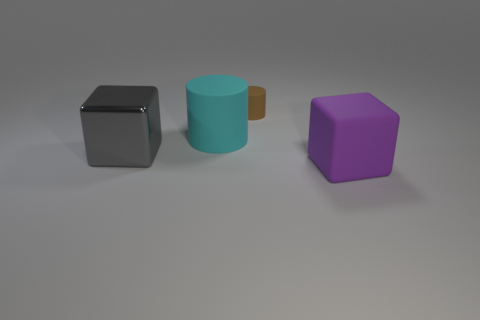Is the size of the cyan matte object the same as the purple thing?
Your response must be concise. Yes. Are there more large cylinders that are behind the big rubber block than cyan cylinders that are in front of the large gray cube?
Your answer should be very brief. Yes. How many other things are there of the same size as the gray shiny object?
Provide a succinct answer. 2. Is the number of cyan things in front of the brown cylinder greater than the number of small purple objects?
Your answer should be compact. Yes. Is there any other thing that has the same color as the large rubber block?
Provide a succinct answer. No. The large matte thing that is right of the large object that is behind the large gray metal thing is what shape?
Make the answer very short. Cube. Is the number of tiny cylinders greater than the number of small gray objects?
Your response must be concise. Yes. How many large objects are on the right side of the large matte cylinder and to the left of the big cyan thing?
Ensure brevity in your answer.  0. There is a large cyan rubber thing on the left side of the small brown rubber object; how many large cylinders are behind it?
Your response must be concise. 0. What number of things are purple rubber objects to the right of the tiny matte thing or matte objects that are behind the big purple thing?
Your response must be concise. 3. 